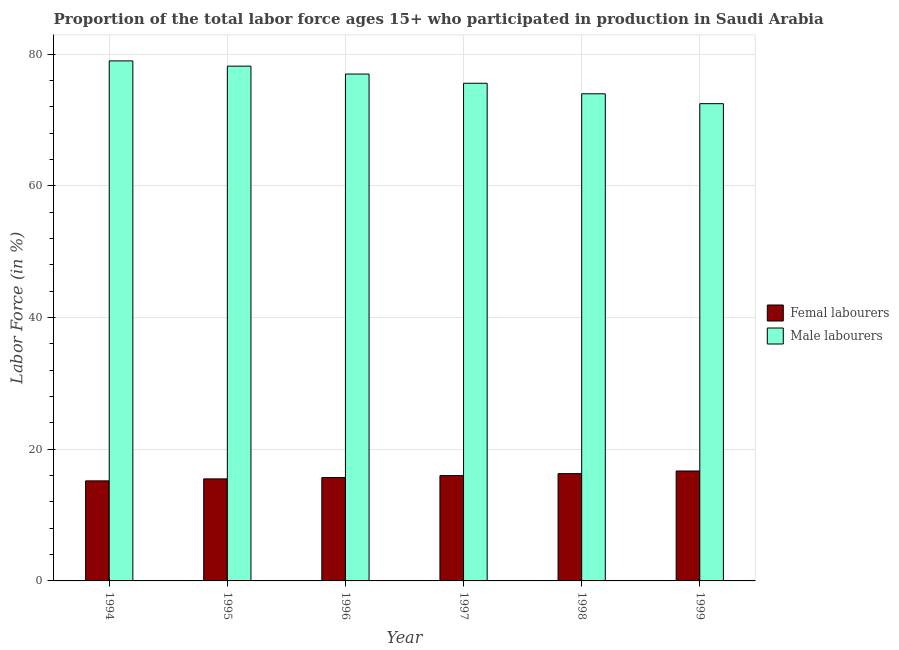How many different coloured bars are there?
Your answer should be very brief. 2. How many groups of bars are there?
Offer a terse response. 6. How many bars are there on the 5th tick from the left?
Your answer should be compact. 2. How many bars are there on the 2nd tick from the right?
Provide a succinct answer. 2. What is the label of the 4th group of bars from the left?
Provide a short and direct response. 1997. In how many cases, is the number of bars for a given year not equal to the number of legend labels?
Your answer should be very brief. 0. What is the percentage of female labor force in 1994?
Give a very brief answer. 15.2. Across all years, what is the maximum percentage of male labour force?
Make the answer very short. 79. Across all years, what is the minimum percentage of female labor force?
Offer a very short reply. 15.2. What is the total percentage of male labour force in the graph?
Provide a succinct answer. 456.3. What is the difference between the percentage of male labour force in 1995 and that in 1996?
Keep it short and to the point. 1.2. What is the difference between the percentage of female labor force in 1997 and the percentage of male labour force in 1996?
Your response must be concise. 0.3. What is the average percentage of male labour force per year?
Offer a very short reply. 76.05. What is the ratio of the percentage of male labour force in 1995 to that in 1996?
Your answer should be very brief. 1.02. What is the difference between the highest and the second highest percentage of female labor force?
Offer a very short reply. 0.4. In how many years, is the percentage of male labour force greater than the average percentage of male labour force taken over all years?
Offer a very short reply. 3. What does the 2nd bar from the left in 1998 represents?
Offer a terse response. Male labourers. What does the 2nd bar from the right in 1995 represents?
Give a very brief answer. Femal labourers. Are all the bars in the graph horizontal?
Ensure brevity in your answer.  No. How many years are there in the graph?
Provide a succinct answer. 6. Are the values on the major ticks of Y-axis written in scientific E-notation?
Keep it short and to the point. No. Does the graph contain any zero values?
Your answer should be compact. No. Where does the legend appear in the graph?
Your answer should be very brief. Center right. How many legend labels are there?
Your response must be concise. 2. How are the legend labels stacked?
Your response must be concise. Vertical. What is the title of the graph?
Keep it short and to the point. Proportion of the total labor force ages 15+ who participated in production in Saudi Arabia. Does "International Tourists" appear as one of the legend labels in the graph?
Your answer should be compact. No. What is the label or title of the X-axis?
Keep it short and to the point. Year. What is the label or title of the Y-axis?
Make the answer very short. Labor Force (in %). What is the Labor Force (in %) of Femal labourers in 1994?
Your response must be concise. 15.2. What is the Labor Force (in %) in Male labourers in 1994?
Provide a short and direct response. 79. What is the Labor Force (in %) of Femal labourers in 1995?
Offer a very short reply. 15.5. What is the Labor Force (in %) of Male labourers in 1995?
Offer a terse response. 78.2. What is the Labor Force (in %) of Femal labourers in 1996?
Provide a short and direct response. 15.7. What is the Labor Force (in %) in Male labourers in 1996?
Keep it short and to the point. 77. What is the Labor Force (in %) of Male labourers in 1997?
Provide a succinct answer. 75.6. What is the Labor Force (in %) in Femal labourers in 1998?
Ensure brevity in your answer.  16.3. What is the Labor Force (in %) of Femal labourers in 1999?
Provide a short and direct response. 16.7. What is the Labor Force (in %) of Male labourers in 1999?
Provide a short and direct response. 72.5. Across all years, what is the maximum Labor Force (in %) of Femal labourers?
Provide a short and direct response. 16.7. Across all years, what is the maximum Labor Force (in %) in Male labourers?
Keep it short and to the point. 79. Across all years, what is the minimum Labor Force (in %) in Femal labourers?
Provide a short and direct response. 15.2. Across all years, what is the minimum Labor Force (in %) of Male labourers?
Keep it short and to the point. 72.5. What is the total Labor Force (in %) of Femal labourers in the graph?
Provide a succinct answer. 95.4. What is the total Labor Force (in %) of Male labourers in the graph?
Provide a succinct answer. 456.3. What is the difference between the Labor Force (in %) of Male labourers in 1994 and that in 1995?
Your response must be concise. 0.8. What is the difference between the Labor Force (in %) of Femal labourers in 1994 and that in 1996?
Make the answer very short. -0.5. What is the difference between the Labor Force (in %) in Male labourers in 1994 and that in 1997?
Make the answer very short. 3.4. What is the difference between the Labor Force (in %) of Femal labourers in 1994 and that in 1998?
Offer a very short reply. -1.1. What is the difference between the Labor Force (in %) in Male labourers in 1994 and that in 1998?
Your answer should be compact. 5. What is the difference between the Labor Force (in %) of Femal labourers in 1994 and that in 1999?
Your response must be concise. -1.5. What is the difference between the Labor Force (in %) in Male labourers in 1994 and that in 1999?
Offer a very short reply. 6.5. What is the difference between the Labor Force (in %) of Femal labourers in 1995 and that in 1996?
Your answer should be very brief. -0.2. What is the difference between the Labor Force (in %) in Male labourers in 1995 and that in 1996?
Provide a succinct answer. 1.2. What is the difference between the Labor Force (in %) in Femal labourers in 1995 and that in 1997?
Keep it short and to the point. -0.5. What is the difference between the Labor Force (in %) in Femal labourers in 1995 and that in 1998?
Your response must be concise. -0.8. What is the difference between the Labor Force (in %) of Femal labourers in 1995 and that in 1999?
Your response must be concise. -1.2. What is the difference between the Labor Force (in %) of Male labourers in 1995 and that in 1999?
Provide a short and direct response. 5.7. What is the difference between the Labor Force (in %) in Femal labourers in 1996 and that in 1997?
Give a very brief answer. -0.3. What is the difference between the Labor Force (in %) of Male labourers in 1996 and that in 1997?
Provide a short and direct response. 1.4. What is the difference between the Labor Force (in %) of Femal labourers in 1996 and that in 1998?
Your answer should be compact. -0.6. What is the difference between the Labor Force (in %) in Male labourers in 1996 and that in 1998?
Keep it short and to the point. 3. What is the difference between the Labor Force (in %) of Femal labourers in 1997 and that in 1998?
Ensure brevity in your answer.  -0.3. What is the difference between the Labor Force (in %) in Male labourers in 1997 and that in 1999?
Your answer should be compact. 3.1. What is the difference between the Labor Force (in %) in Femal labourers in 1994 and the Labor Force (in %) in Male labourers in 1995?
Your answer should be very brief. -63. What is the difference between the Labor Force (in %) in Femal labourers in 1994 and the Labor Force (in %) in Male labourers in 1996?
Offer a terse response. -61.8. What is the difference between the Labor Force (in %) in Femal labourers in 1994 and the Labor Force (in %) in Male labourers in 1997?
Your answer should be very brief. -60.4. What is the difference between the Labor Force (in %) in Femal labourers in 1994 and the Labor Force (in %) in Male labourers in 1998?
Your answer should be compact. -58.8. What is the difference between the Labor Force (in %) in Femal labourers in 1994 and the Labor Force (in %) in Male labourers in 1999?
Provide a short and direct response. -57.3. What is the difference between the Labor Force (in %) in Femal labourers in 1995 and the Labor Force (in %) in Male labourers in 1996?
Your response must be concise. -61.5. What is the difference between the Labor Force (in %) in Femal labourers in 1995 and the Labor Force (in %) in Male labourers in 1997?
Ensure brevity in your answer.  -60.1. What is the difference between the Labor Force (in %) in Femal labourers in 1995 and the Labor Force (in %) in Male labourers in 1998?
Make the answer very short. -58.5. What is the difference between the Labor Force (in %) of Femal labourers in 1995 and the Labor Force (in %) of Male labourers in 1999?
Provide a short and direct response. -57. What is the difference between the Labor Force (in %) of Femal labourers in 1996 and the Labor Force (in %) of Male labourers in 1997?
Offer a terse response. -59.9. What is the difference between the Labor Force (in %) of Femal labourers in 1996 and the Labor Force (in %) of Male labourers in 1998?
Offer a very short reply. -58.3. What is the difference between the Labor Force (in %) in Femal labourers in 1996 and the Labor Force (in %) in Male labourers in 1999?
Offer a terse response. -56.8. What is the difference between the Labor Force (in %) of Femal labourers in 1997 and the Labor Force (in %) of Male labourers in 1998?
Give a very brief answer. -58. What is the difference between the Labor Force (in %) of Femal labourers in 1997 and the Labor Force (in %) of Male labourers in 1999?
Your answer should be compact. -56.5. What is the difference between the Labor Force (in %) of Femal labourers in 1998 and the Labor Force (in %) of Male labourers in 1999?
Make the answer very short. -56.2. What is the average Labor Force (in %) of Femal labourers per year?
Your answer should be compact. 15.9. What is the average Labor Force (in %) of Male labourers per year?
Offer a very short reply. 76.05. In the year 1994, what is the difference between the Labor Force (in %) in Femal labourers and Labor Force (in %) in Male labourers?
Your response must be concise. -63.8. In the year 1995, what is the difference between the Labor Force (in %) of Femal labourers and Labor Force (in %) of Male labourers?
Offer a terse response. -62.7. In the year 1996, what is the difference between the Labor Force (in %) of Femal labourers and Labor Force (in %) of Male labourers?
Offer a very short reply. -61.3. In the year 1997, what is the difference between the Labor Force (in %) in Femal labourers and Labor Force (in %) in Male labourers?
Offer a terse response. -59.6. In the year 1998, what is the difference between the Labor Force (in %) in Femal labourers and Labor Force (in %) in Male labourers?
Keep it short and to the point. -57.7. In the year 1999, what is the difference between the Labor Force (in %) of Femal labourers and Labor Force (in %) of Male labourers?
Ensure brevity in your answer.  -55.8. What is the ratio of the Labor Force (in %) in Femal labourers in 1994 to that in 1995?
Your answer should be compact. 0.98. What is the ratio of the Labor Force (in %) in Male labourers in 1994 to that in 1995?
Provide a short and direct response. 1.01. What is the ratio of the Labor Force (in %) in Femal labourers in 1994 to that in 1996?
Give a very brief answer. 0.97. What is the ratio of the Labor Force (in %) of Femal labourers in 1994 to that in 1997?
Provide a succinct answer. 0.95. What is the ratio of the Labor Force (in %) of Male labourers in 1994 to that in 1997?
Offer a terse response. 1.04. What is the ratio of the Labor Force (in %) of Femal labourers in 1994 to that in 1998?
Ensure brevity in your answer.  0.93. What is the ratio of the Labor Force (in %) of Male labourers in 1994 to that in 1998?
Offer a terse response. 1.07. What is the ratio of the Labor Force (in %) of Femal labourers in 1994 to that in 1999?
Your answer should be compact. 0.91. What is the ratio of the Labor Force (in %) in Male labourers in 1994 to that in 1999?
Offer a very short reply. 1.09. What is the ratio of the Labor Force (in %) in Femal labourers in 1995 to that in 1996?
Keep it short and to the point. 0.99. What is the ratio of the Labor Force (in %) in Male labourers in 1995 to that in 1996?
Your answer should be compact. 1.02. What is the ratio of the Labor Force (in %) of Femal labourers in 1995 to that in 1997?
Offer a terse response. 0.97. What is the ratio of the Labor Force (in %) in Male labourers in 1995 to that in 1997?
Make the answer very short. 1.03. What is the ratio of the Labor Force (in %) in Femal labourers in 1995 to that in 1998?
Keep it short and to the point. 0.95. What is the ratio of the Labor Force (in %) of Male labourers in 1995 to that in 1998?
Offer a terse response. 1.06. What is the ratio of the Labor Force (in %) in Femal labourers in 1995 to that in 1999?
Provide a succinct answer. 0.93. What is the ratio of the Labor Force (in %) of Male labourers in 1995 to that in 1999?
Offer a terse response. 1.08. What is the ratio of the Labor Force (in %) in Femal labourers in 1996 to that in 1997?
Provide a short and direct response. 0.98. What is the ratio of the Labor Force (in %) of Male labourers in 1996 to that in 1997?
Provide a short and direct response. 1.02. What is the ratio of the Labor Force (in %) of Femal labourers in 1996 to that in 1998?
Provide a short and direct response. 0.96. What is the ratio of the Labor Force (in %) of Male labourers in 1996 to that in 1998?
Provide a succinct answer. 1.04. What is the ratio of the Labor Force (in %) in Femal labourers in 1996 to that in 1999?
Make the answer very short. 0.94. What is the ratio of the Labor Force (in %) of Male labourers in 1996 to that in 1999?
Your answer should be very brief. 1.06. What is the ratio of the Labor Force (in %) of Femal labourers in 1997 to that in 1998?
Provide a short and direct response. 0.98. What is the ratio of the Labor Force (in %) of Male labourers in 1997 to that in 1998?
Provide a short and direct response. 1.02. What is the ratio of the Labor Force (in %) of Femal labourers in 1997 to that in 1999?
Give a very brief answer. 0.96. What is the ratio of the Labor Force (in %) of Male labourers in 1997 to that in 1999?
Your answer should be very brief. 1.04. What is the ratio of the Labor Force (in %) in Male labourers in 1998 to that in 1999?
Provide a short and direct response. 1.02. What is the difference between the highest and the second highest Labor Force (in %) in Femal labourers?
Make the answer very short. 0.4. What is the difference between the highest and the second highest Labor Force (in %) of Male labourers?
Give a very brief answer. 0.8. 